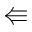<formula> <loc_0><loc_0><loc_500><loc_500>\L l e f t a r r o w</formula> 